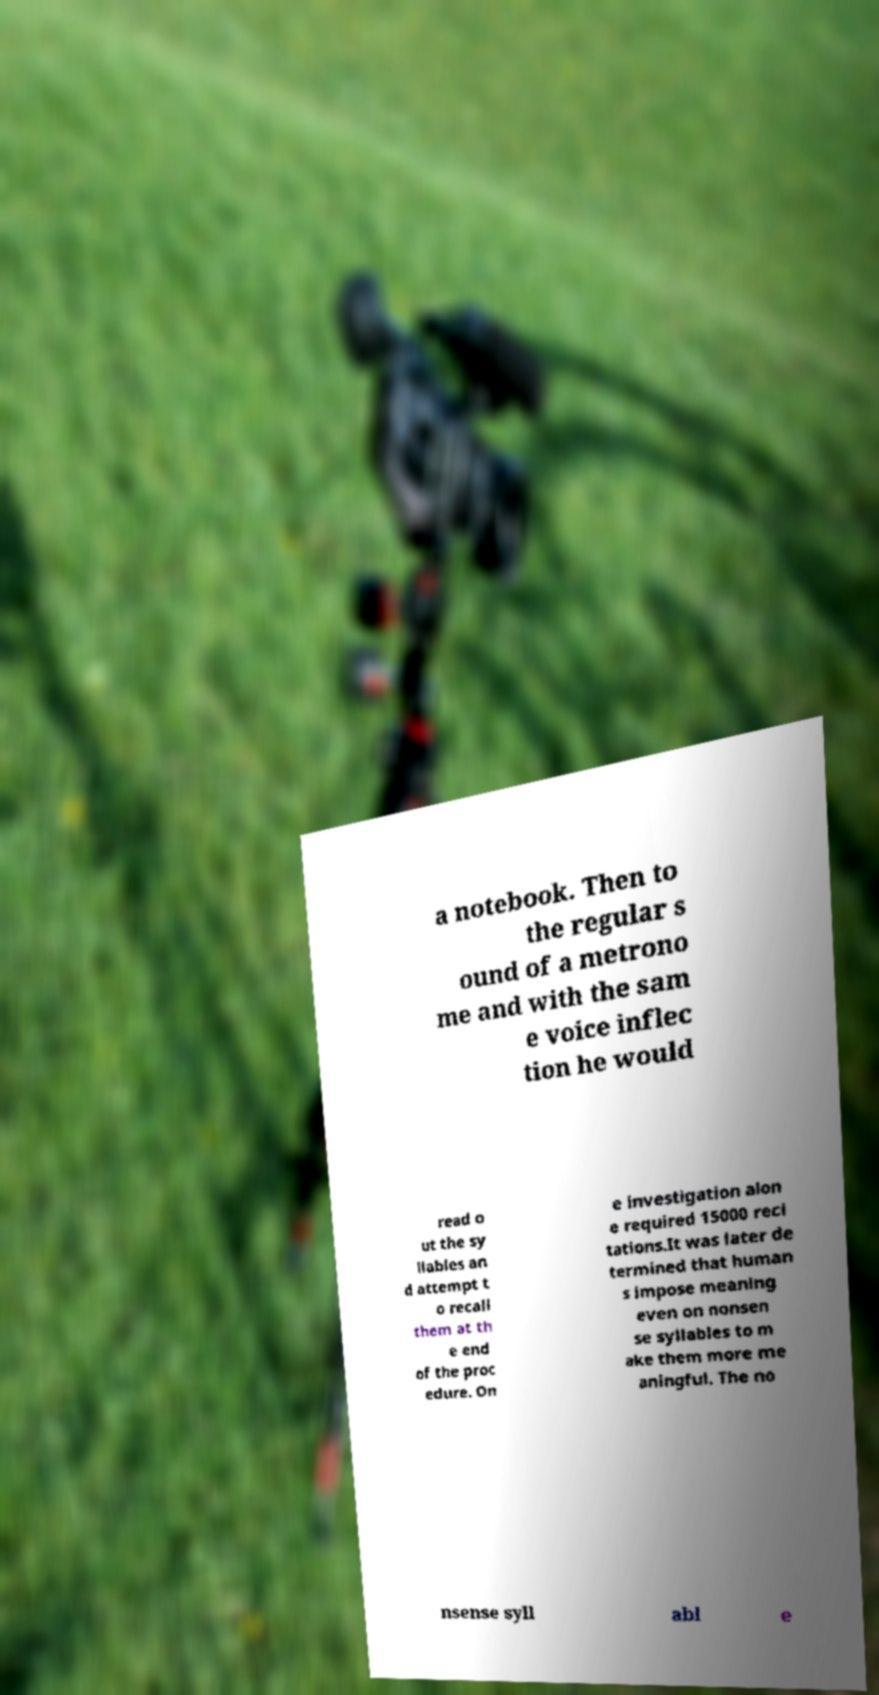For documentation purposes, I need the text within this image transcribed. Could you provide that? a notebook. Then to the regular s ound of a metrono me and with the sam e voice inflec tion he would read o ut the sy llables an d attempt t o recall them at th e end of the proc edure. On e investigation alon e required 15000 reci tations.It was later de termined that human s impose meaning even on nonsen se syllables to m ake them more me aningful. The no nsense syll abl e 